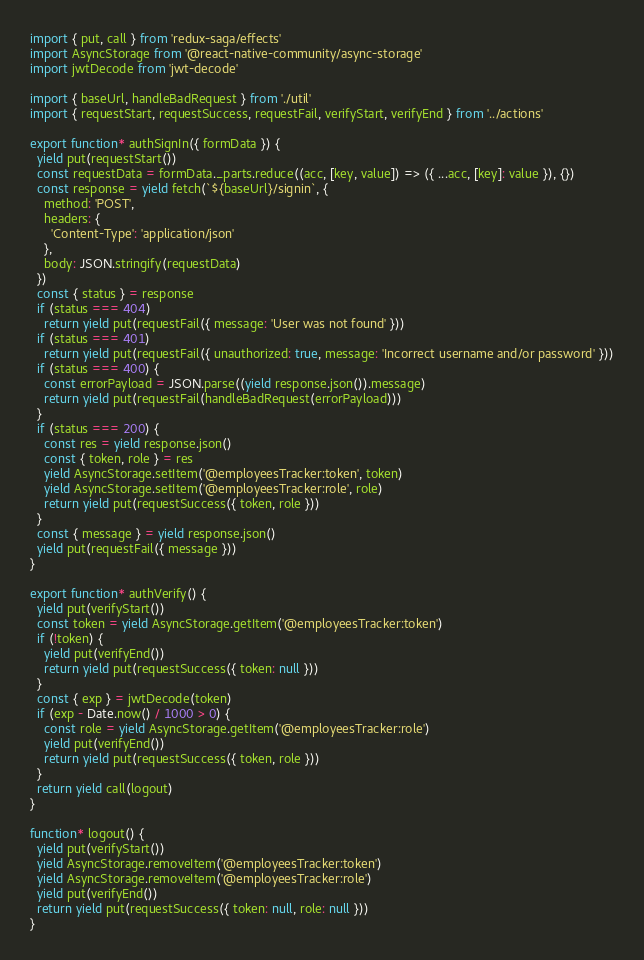Convert code to text. <code><loc_0><loc_0><loc_500><loc_500><_JavaScript_>import { put, call } from 'redux-saga/effects'
import AsyncStorage from '@react-native-community/async-storage'
import jwtDecode from 'jwt-decode'

import { baseUrl, handleBadRequest } from './util'
import { requestStart, requestSuccess, requestFail, verifyStart, verifyEnd } from '../actions'

export function* authSignIn({ formData }) {
  yield put(requestStart())
  const requestData = formData._parts.reduce((acc, [key, value]) => ({ ...acc, [key]: value }), {})
  const response = yield fetch(`${baseUrl}/signin`, {
    method: 'POST',
    headers: {
      'Content-Type': 'application/json'
    },
    body: JSON.stringify(requestData)
  })
  const { status } = response
  if (status === 404)
    return yield put(requestFail({ message: 'User was not found' }))
  if (status === 401)
    return yield put(requestFail({ unauthorized: true, message: 'Incorrect username and/or password' }))
  if (status === 400) {
    const errorPayload = JSON.parse((yield response.json()).message)
    return yield put(requestFail(handleBadRequest(errorPayload)))
  }
  if (status === 200) {
    const res = yield response.json()
    const { token, role } = res
    yield AsyncStorage.setItem('@employeesTracker:token', token)
    yield AsyncStorage.setItem('@employeesTracker:role', role)
    return yield put(requestSuccess({ token, role }))
  }
  const { message } = yield response.json()
  yield put(requestFail({ message }))
}

export function* authVerify() {
  yield put(verifyStart())
  const token = yield AsyncStorage.getItem('@employeesTracker:token')
  if (!token) {
    yield put(verifyEnd())
    return yield put(requestSuccess({ token: null }))
  }
  const { exp } = jwtDecode(token)
  if (exp - Date.now() / 1000 > 0) {
    const role = yield AsyncStorage.getItem('@employeesTracker:role')
    yield put(verifyEnd())
    return yield put(requestSuccess({ token, role }))
  }
  return yield call(logout)
}

function* logout() {
  yield put(verifyStart())
  yield AsyncStorage.removeItem('@employeesTracker:token')
  yield AsyncStorage.removeItem('@employeesTracker:role')
  yield put(verifyEnd())
  return yield put(requestSuccess({ token: null, role: null }))
}</code> 